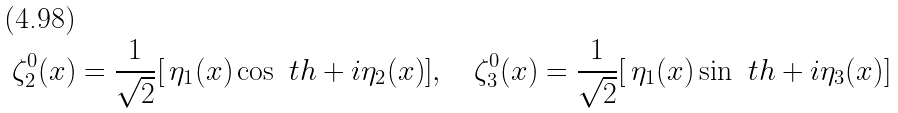<formula> <loc_0><loc_0><loc_500><loc_500>\zeta _ { 2 } ^ { 0 } ( x ) = \frac { 1 } { \sqrt { 2 } } [ \, \eta _ { 1 } ( x ) \cos \ t h + i \eta _ { 2 } ( x ) ] , \quad \zeta _ { 3 } ^ { 0 } ( x ) = \frac { 1 } { \sqrt { 2 } } [ \, \eta _ { 1 } ( x ) \sin \ t h + i \eta _ { 3 } ( x ) ]</formula> 